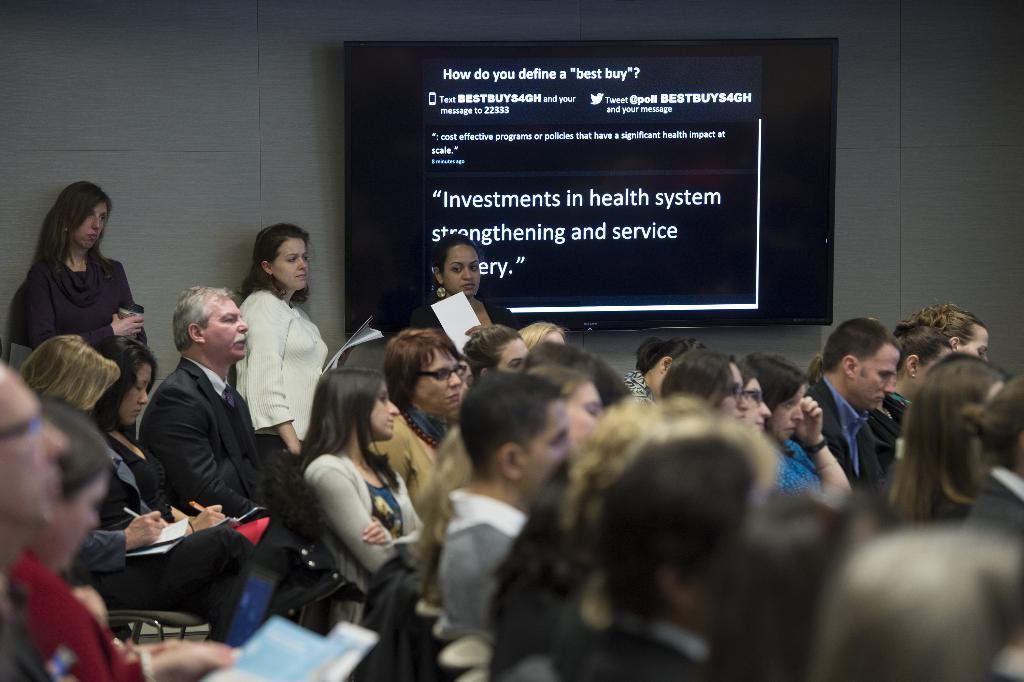Could you give a brief overview of what you see in this image? In this image I can see people seated in a room. Few people are holding pen and papers. 3 people are standing at the back. There is a screen on a wall. 